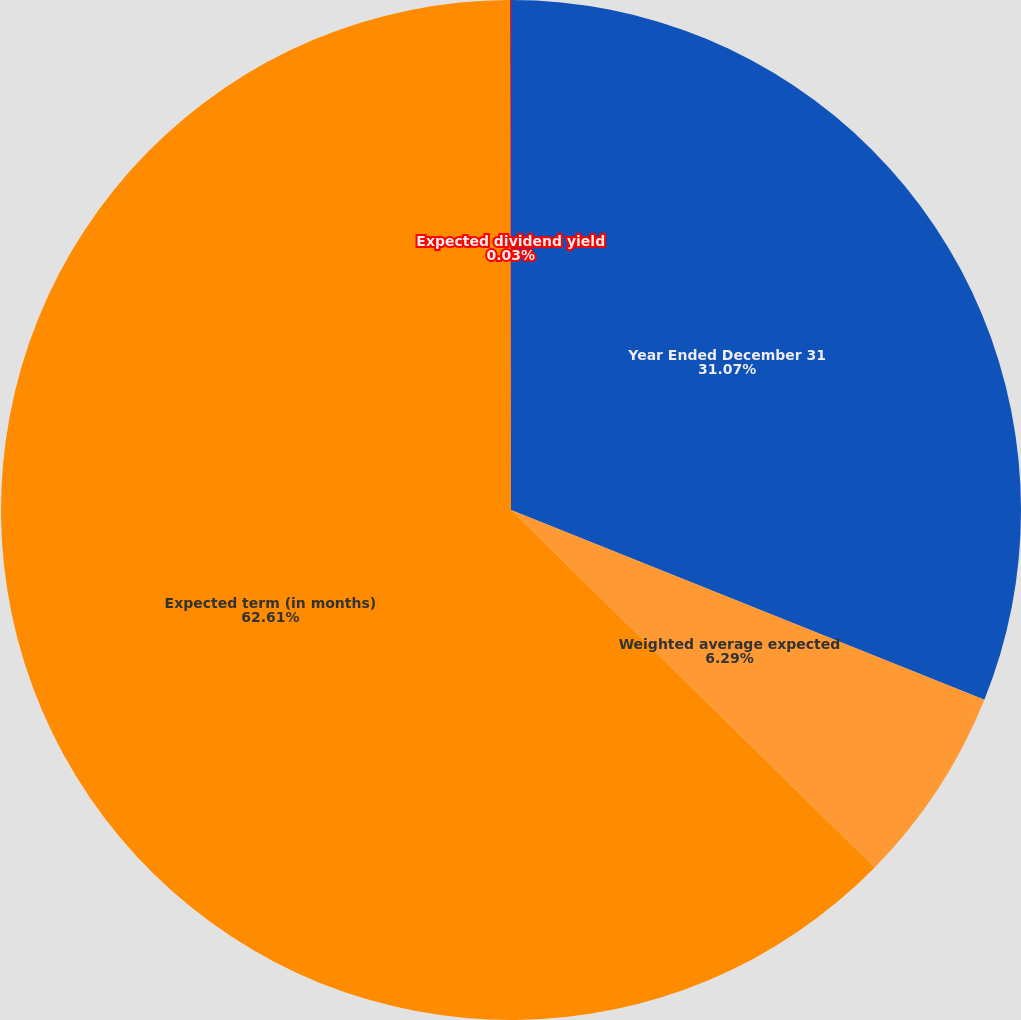Convert chart to OTSL. <chart><loc_0><loc_0><loc_500><loc_500><pie_chart><fcel>Year Ended December 31<fcel>Weighted average expected<fcel>Expected term (in months)<fcel>Expected dividend yield<nl><fcel>31.07%<fcel>6.29%<fcel>62.61%<fcel>0.03%<nl></chart> 